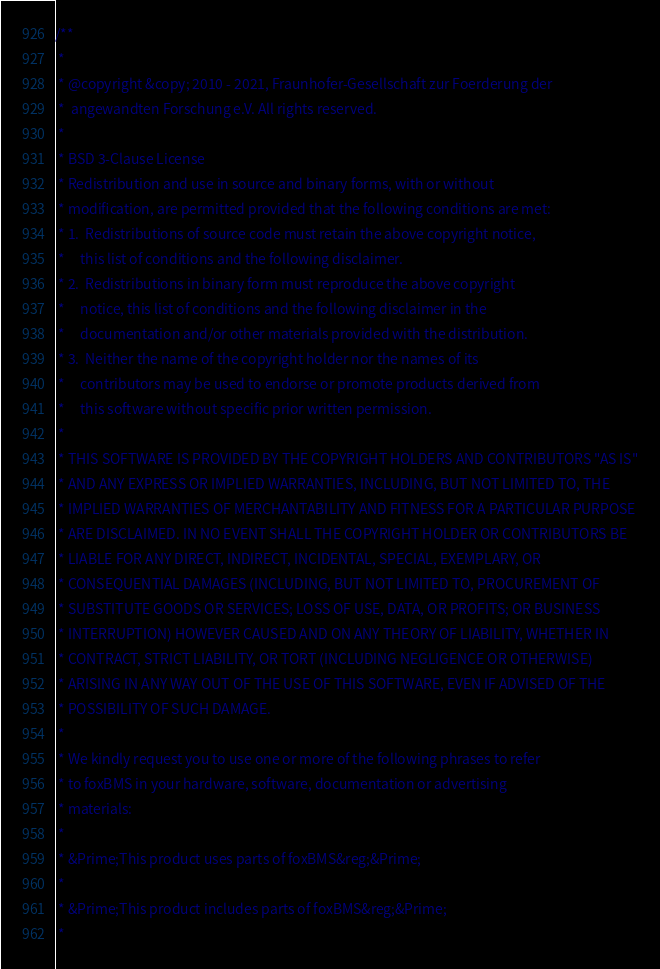Convert code to text. <code><loc_0><loc_0><loc_500><loc_500><_C_>/**
 *
 * @copyright &copy; 2010 - 2021, Fraunhofer-Gesellschaft zur Foerderung der
 *  angewandten Forschung e.V. All rights reserved.
 *
 * BSD 3-Clause License
 * Redistribution and use in source and binary forms, with or without
 * modification, are permitted provided that the following conditions are met:
 * 1.  Redistributions of source code must retain the above copyright notice,
 *     this list of conditions and the following disclaimer.
 * 2.  Redistributions in binary form must reproduce the above copyright
 *     notice, this list of conditions and the following disclaimer in the
 *     documentation and/or other materials provided with the distribution.
 * 3.  Neither the name of the copyright holder nor the names of its
 *     contributors may be used to endorse or promote products derived from
 *     this software without specific prior written permission.
 *
 * THIS SOFTWARE IS PROVIDED BY THE COPYRIGHT HOLDERS AND CONTRIBUTORS "AS IS"
 * AND ANY EXPRESS OR IMPLIED WARRANTIES, INCLUDING, BUT NOT LIMITED TO, THE
 * IMPLIED WARRANTIES OF MERCHANTABILITY AND FITNESS FOR A PARTICULAR PURPOSE
 * ARE DISCLAIMED. IN NO EVENT SHALL THE COPYRIGHT HOLDER OR CONTRIBUTORS BE
 * LIABLE FOR ANY DIRECT, INDIRECT, INCIDENTAL, SPECIAL, EXEMPLARY, OR
 * CONSEQUENTIAL DAMAGES (INCLUDING, BUT NOT LIMITED TO, PROCUREMENT OF
 * SUBSTITUTE GOODS OR SERVICES; LOSS OF USE, DATA, OR PROFITS; OR BUSINESS
 * INTERRUPTION) HOWEVER CAUSED AND ON ANY THEORY OF LIABILITY, WHETHER IN
 * CONTRACT, STRICT LIABILITY, OR TORT (INCLUDING NEGLIGENCE OR OTHERWISE)
 * ARISING IN ANY WAY OUT OF THE USE OF THIS SOFTWARE, EVEN IF ADVISED OF THE
 * POSSIBILITY OF SUCH DAMAGE.
 *
 * We kindly request you to use one or more of the following phrases to refer
 * to foxBMS in your hardware, software, documentation or advertising
 * materials:
 *
 * &Prime;This product uses parts of foxBMS&reg;&Prime;
 *
 * &Prime;This product includes parts of foxBMS&reg;&Prime;
 *</code> 